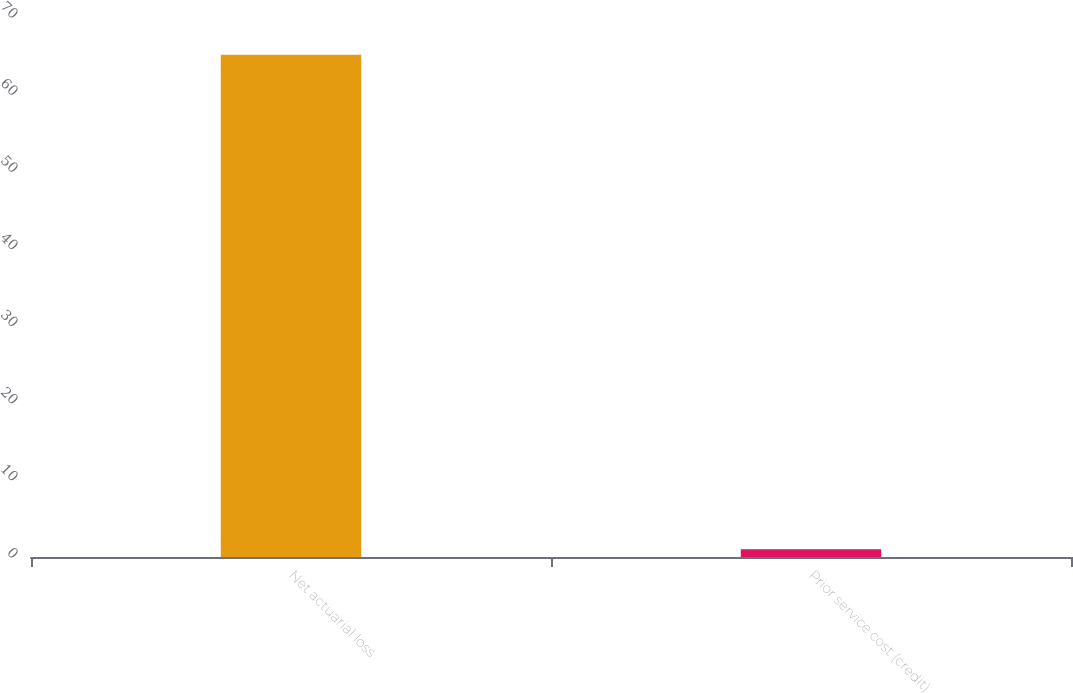Convert chart. <chart><loc_0><loc_0><loc_500><loc_500><bar_chart><fcel>Net actuarial loss<fcel>Prior service cost (credit)<nl><fcel>65.1<fcel>1<nl></chart> 